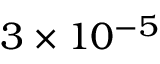Convert formula to latex. <formula><loc_0><loc_0><loc_500><loc_500>3 \times 1 0 ^ { - 5 }</formula> 